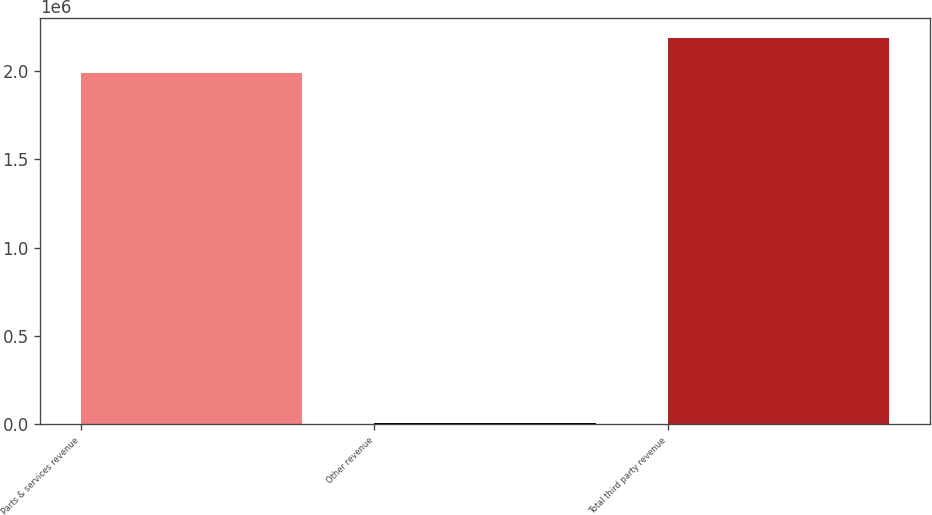Convert chart to OTSL. <chart><loc_0><loc_0><loc_500><loc_500><bar_chart><fcel>Parts & services revenue<fcel>Other revenue<fcel>Total third party revenue<nl><fcel>1.99111e+06<fcel>4279<fcel>2.19022e+06<nl></chart> 